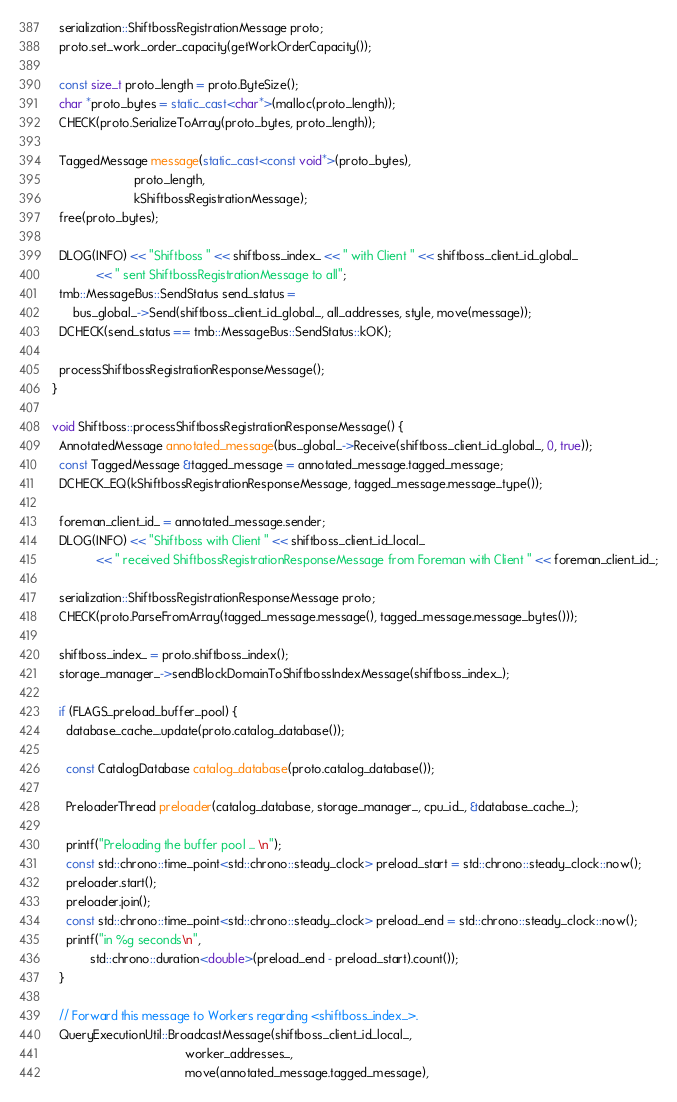Convert code to text. <code><loc_0><loc_0><loc_500><loc_500><_C++_>
  serialization::ShiftbossRegistrationMessage proto;
  proto.set_work_order_capacity(getWorkOrderCapacity());

  const size_t proto_length = proto.ByteSize();
  char *proto_bytes = static_cast<char*>(malloc(proto_length));
  CHECK(proto.SerializeToArray(proto_bytes, proto_length));

  TaggedMessage message(static_cast<const void*>(proto_bytes),
                        proto_length,
                        kShiftbossRegistrationMessage);
  free(proto_bytes);

  DLOG(INFO) << "Shiftboss " << shiftboss_index_ << " with Client " << shiftboss_client_id_global_
             << " sent ShiftbossRegistrationMessage to all";
  tmb::MessageBus::SendStatus send_status =
      bus_global_->Send(shiftboss_client_id_global_, all_addresses, style, move(message));
  DCHECK(send_status == tmb::MessageBus::SendStatus::kOK);

  processShiftbossRegistrationResponseMessage();
}

void Shiftboss::processShiftbossRegistrationResponseMessage() {
  AnnotatedMessage annotated_message(bus_global_->Receive(shiftboss_client_id_global_, 0, true));
  const TaggedMessage &tagged_message = annotated_message.tagged_message;
  DCHECK_EQ(kShiftbossRegistrationResponseMessage, tagged_message.message_type());

  foreman_client_id_ = annotated_message.sender;
  DLOG(INFO) << "Shiftboss with Client " << shiftboss_client_id_local_
             << " received ShiftbossRegistrationResponseMessage from Foreman with Client " << foreman_client_id_;

  serialization::ShiftbossRegistrationResponseMessage proto;
  CHECK(proto.ParseFromArray(tagged_message.message(), tagged_message.message_bytes()));

  shiftboss_index_ = proto.shiftboss_index();
  storage_manager_->sendBlockDomainToShiftbossIndexMessage(shiftboss_index_);

  if (FLAGS_preload_buffer_pool) {
    database_cache_.update(proto.catalog_database());

    const CatalogDatabase catalog_database(proto.catalog_database());

    PreloaderThread preloader(catalog_database, storage_manager_, cpu_id_, &database_cache_);

    printf("Preloading the buffer pool ... \n");
    const std::chrono::time_point<std::chrono::steady_clock> preload_start = std::chrono::steady_clock::now();
    preloader.start();
    preloader.join();
    const std::chrono::time_point<std::chrono::steady_clock> preload_end = std::chrono::steady_clock::now();
    printf("in %g seconds\n",
           std::chrono::duration<double>(preload_end - preload_start).count());
  }

  // Forward this message to Workers regarding <shiftboss_index_>.
  QueryExecutionUtil::BroadcastMessage(shiftboss_client_id_local_,
                                       worker_addresses_,
                                       move(annotated_message.tagged_message),</code> 